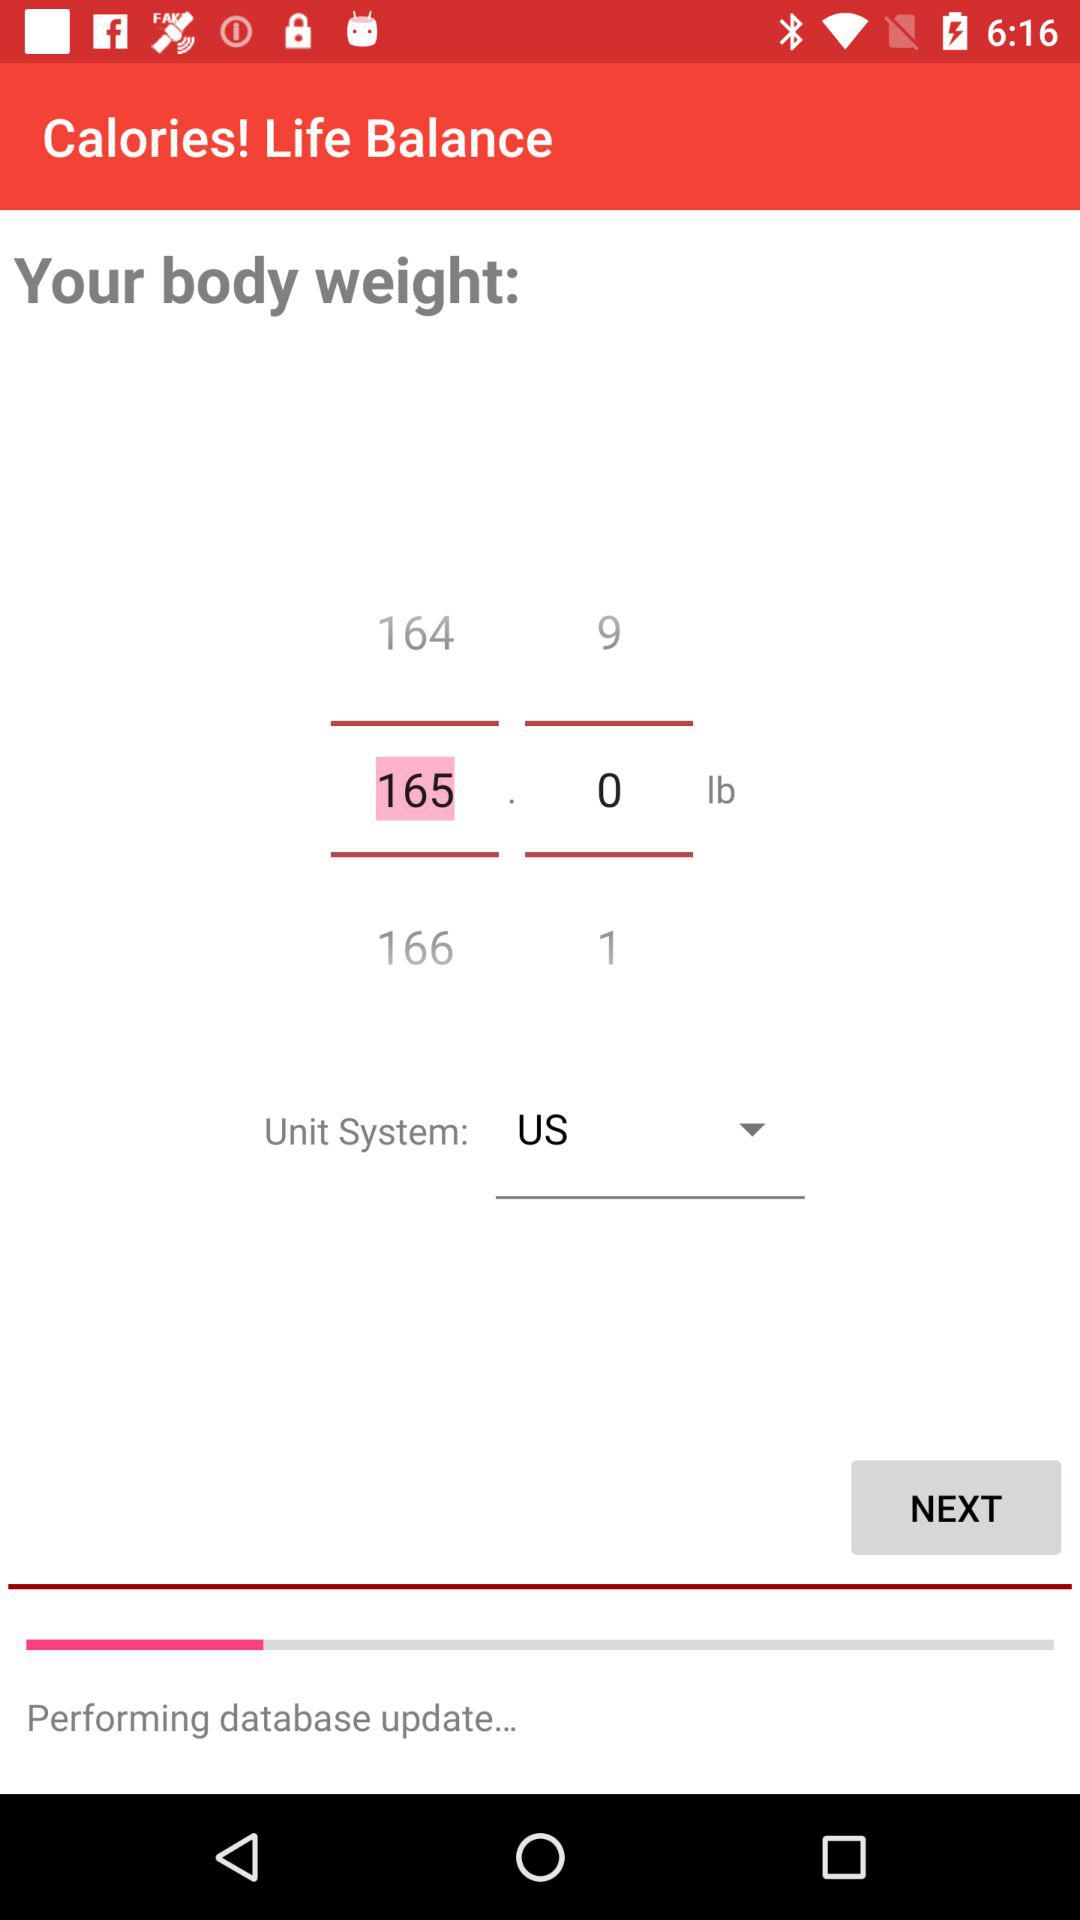What is the unit system used in this app?
Answer the question using a single word or phrase. US 